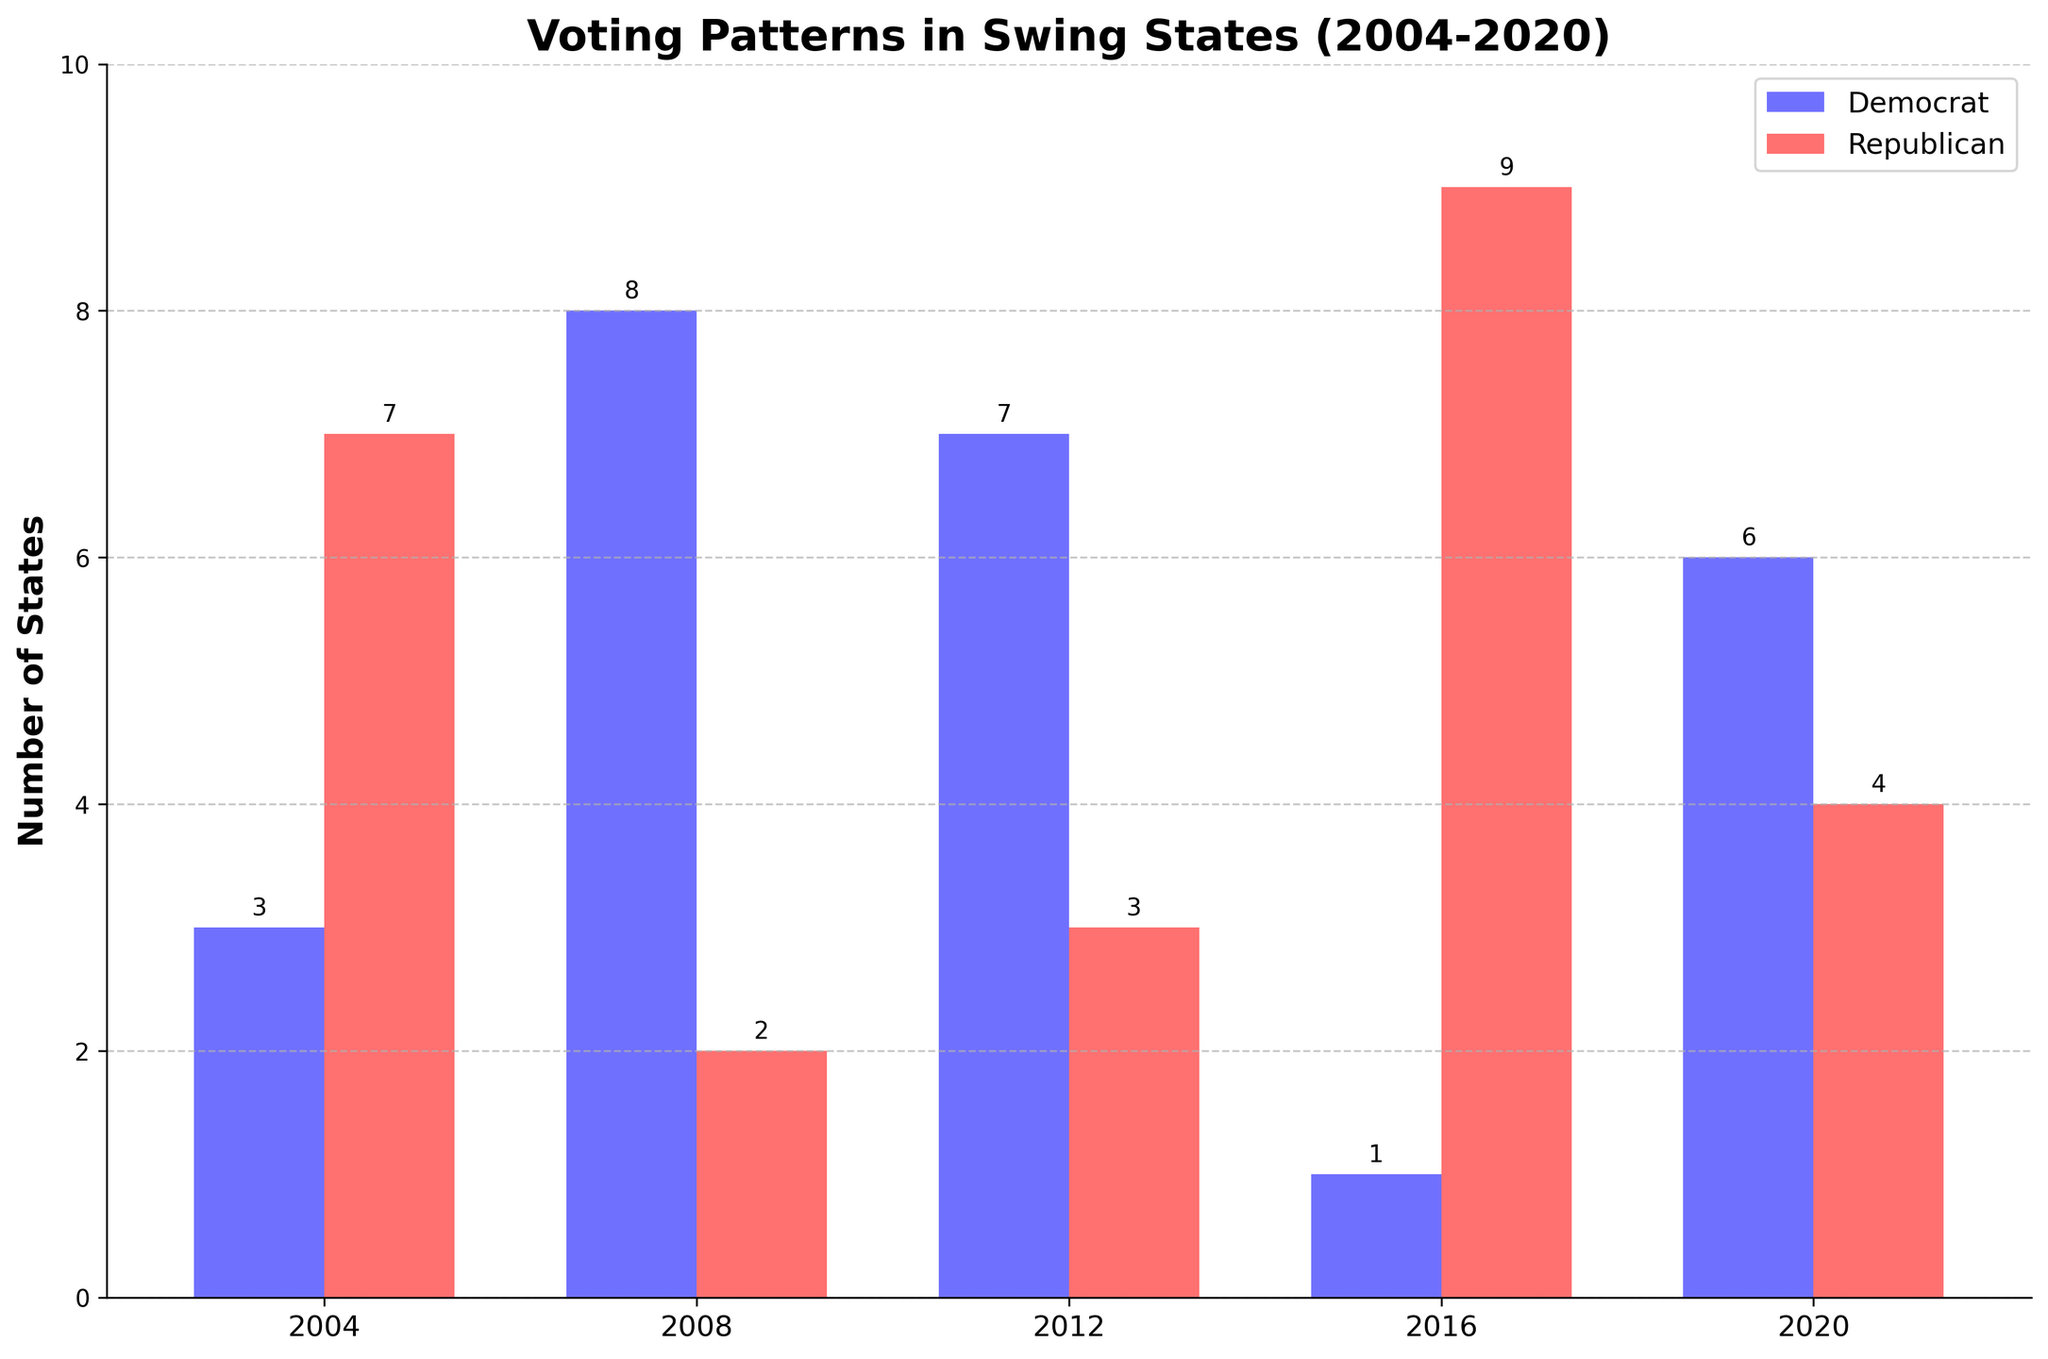How many times did Democrats win more states than Republicans across the five elections? Count the number of bars where the height of the blue bar (Democrats) is taller than the red bar (Republicans): there are three (2008, 2012, 2020)
Answer: Three times In which years did Republicans win more states than Democrats? Look for the years where the height of the red bar (Republicans) is taller than the blue bar (Democrats): 2004, 2016
Answer: 2004 and 2016 Which year saw the highest number of states won by Democrats? Find the tallest blue bar. The tallest blue bar is in 2008
Answer: 2008 How many states did Democrats win in the year they won the fewest states? Find the shortest blue bar. The shortest blue bar is in 2004 and 2016, and its height is 3
Answer: 3 How many swing states did Republicans win in the year 2020? Refer to the exact height of the red bar for the year 2020, which is 4
Answer: 4 By how many states did the Democrats outperform Republicans in the most lopsided year? Find the year with the largest difference in height between the blue and red bars, which is 2008 with a difference of 7 - 3 = 4
Answer: 4 In which year did both parties win an equal number of states, if any? Check if any bars have equal heights for blue and red for every year. No such year exists
Answer: None What is the average number of states won by Democrats across all five elections? Sum the heights of the blue bars and divide by 5: (3 + 7 + 6 + 3 + 5) / 5 = 24 / 5 = 4.8
Answer: 4.8 What trend can you observe in terms of Democratic wins in swing states from 2004 to 2020? Observe the heights of the blue bars for each year: 2004 (3), 2008 (7), 2012 (6), 2016 (3), 2020 (5). Generally, there is fluctuation but a decline after 2012 and a small recovery in 2020
Answer: Fluctuating, with a decline after 2012 and a recovery in 2020 Which year had the smallest difference between the number of states won by Democrats and Republicans? Calculate the difference between the heights of the blue and red bars for each year and find the smallest: 2004 (3 - 7 = 4), 2008 (7 - 3 = 4), 2012 (6 - 3 = 3), 2016 (3 - 7 = 4), 2020 (5 - 4 = 1). The smallest difference is 1 in 2020
Answer: 2020 